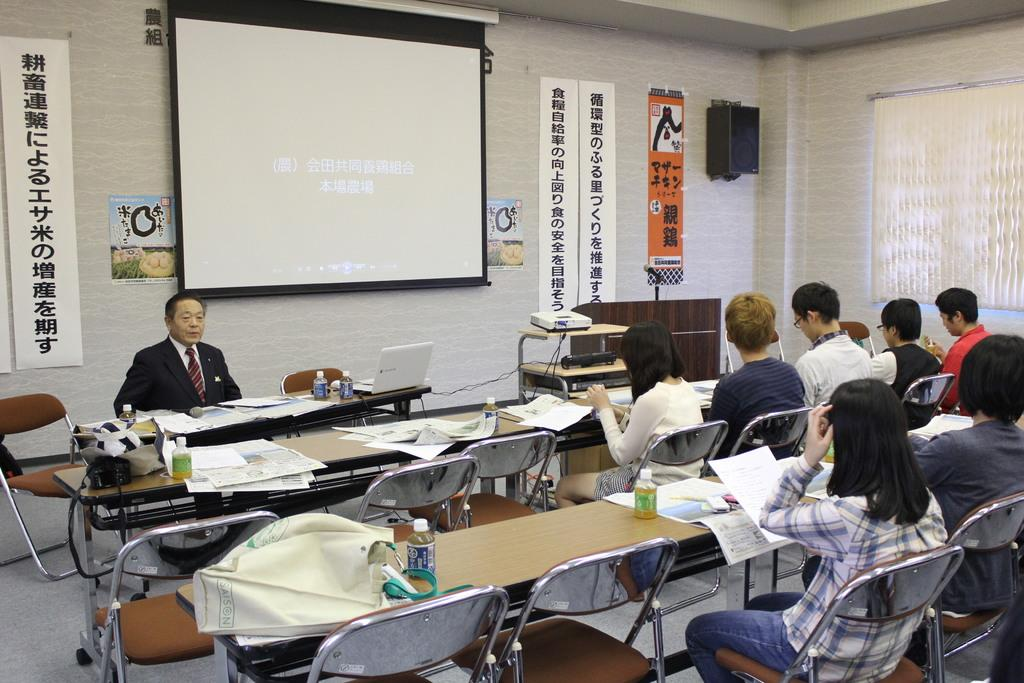What type of setting is shown in the image? The image depicts a classroom. What are the people in the image doing? People are seated on chairs in the classroom. What items can be seen on the table in the image? There are books on the table. Can you describe the person seated in front of the people? A man is seated in front of the people. What is being used to display information in the image? A projected screen is visible. What device might be used to control the projected screen? A laptop is present in the image. What type of horse can be seen wearing a coat in the image? There is no horse or coat present in the image; it depicts a classroom setting. 